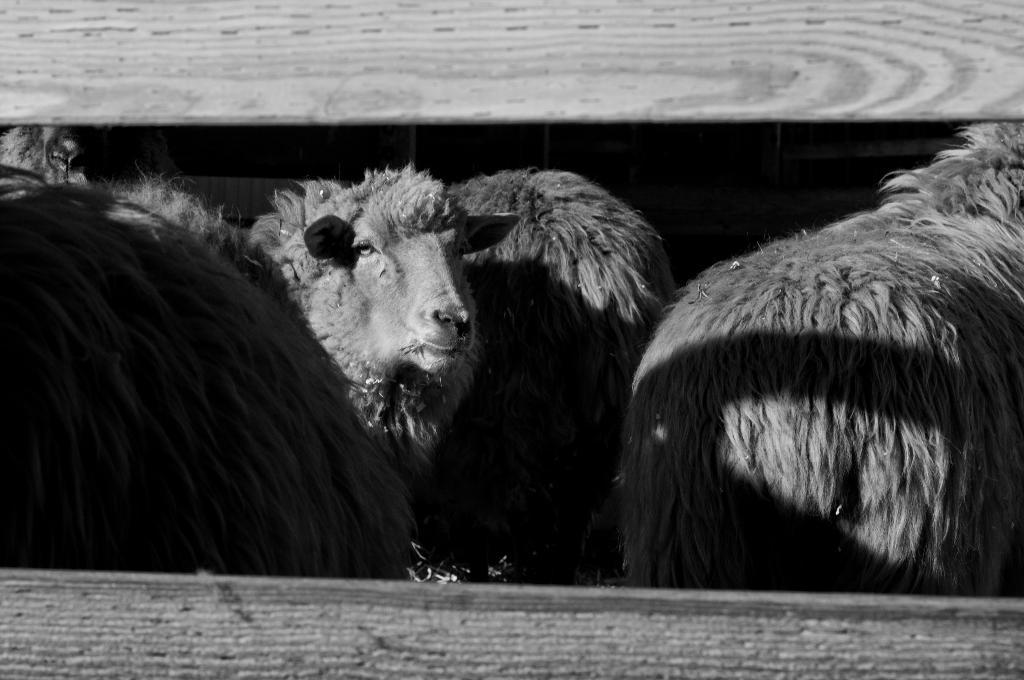What is the color scheme of the image? The image is black and white. What animals are present in the image? There are sheep in the image. Can you describe the behavior of one of the sheep? One of the sheep is looking at the camera. Is there any indication of a barrier or enclosure in the image? There might be a wooden fence in front of the picture. What type of patch is being sewn onto the thumb of the sheep in the image? There is no patch or thumb present in the image; it features black and white sheep with no visible sewing or clothing. 